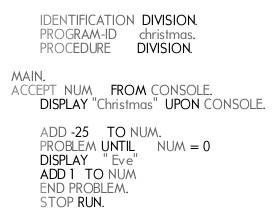<code> <loc_0><loc_0><loc_500><loc_500><_COBOL_>		IDENTIFICATION  DIVISION.
		PROGRAM-ID      christmas.
		PROCEDURE       DIVISION.
		
MAIN.
ACCEPT  NUM     FROM CONSOLE.
   	 	DISPLAY "Christmas"  UPON CONSOLE.

    	ADD -25     TO NUM.
    	PROBLEM UNTIL      NUM = 0
        DISPLAY    " Eve"
        ADD 1   TO NUM
    	END PROBLEM.
    	STOP RUN.
</code> 